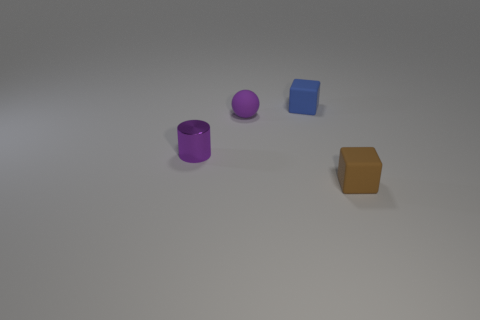Add 3 small purple shiny things. How many objects exist? 7 Subtract all cylinders. How many objects are left? 3 Subtract all small blue matte blocks. Subtract all matte blocks. How many objects are left? 1 Add 2 purple cylinders. How many purple cylinders are left? 3 Add 2 tiny brown matte cylinders. How many tiny brown matte cylinders exist? 2 Subtract 0 brown cylinders. How many objects are left? 4 